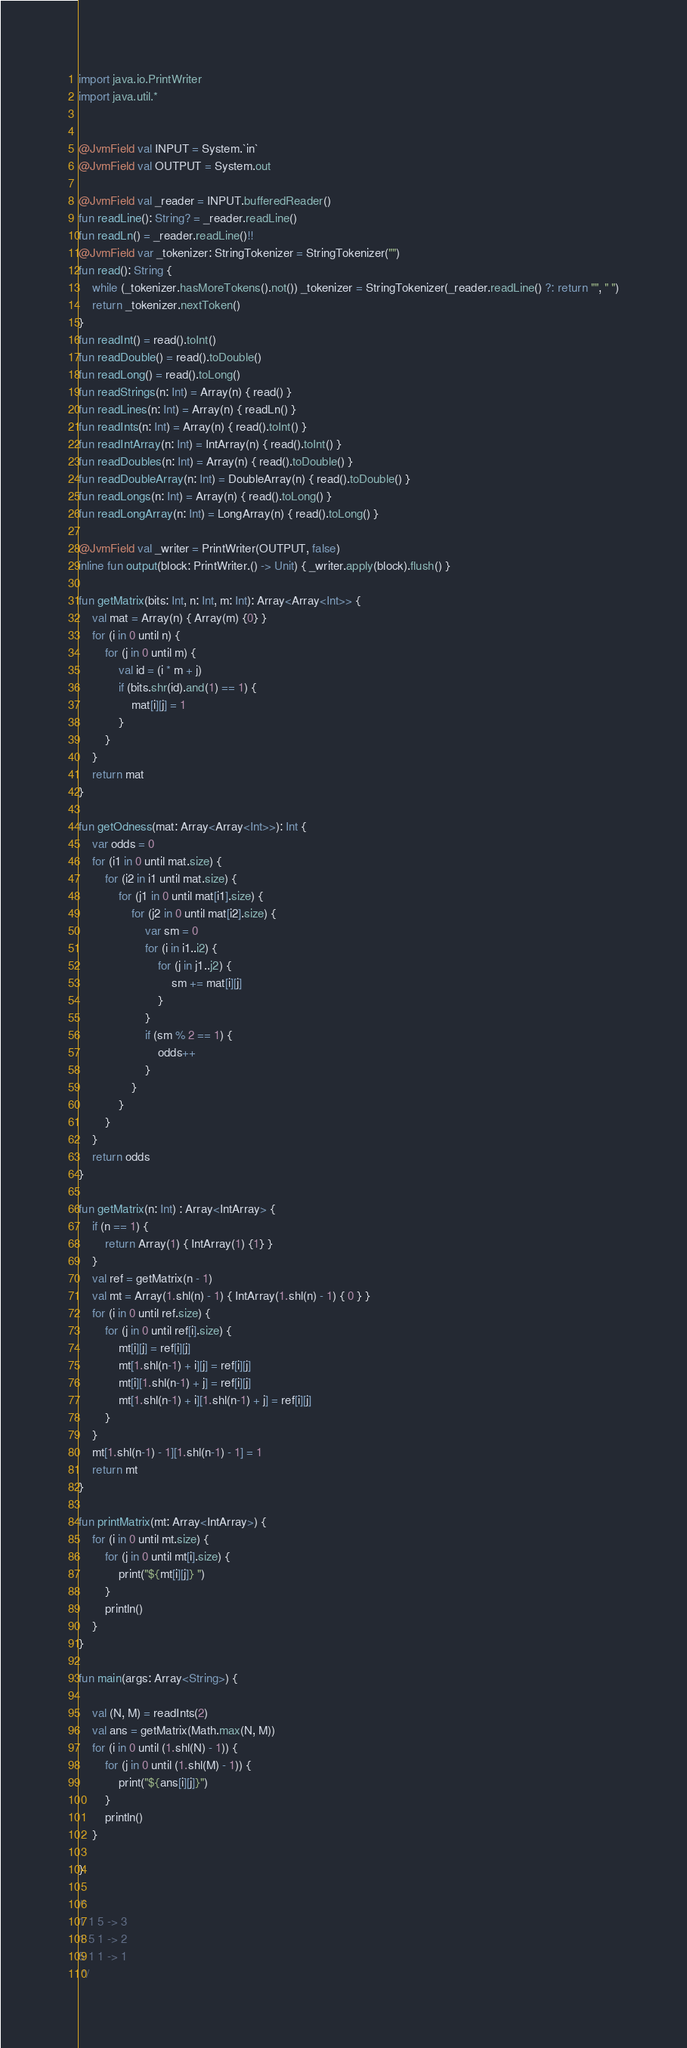<code> <loc_0><loc_0><loc_500><loc_500><_Kotlin_>import java.io.PrintWriter
import java.util.*


@JvmField val INPUT = System.`in`
@JvmField val OUTPUT = System.out

@JvmField val _reader = INPUT.bufferedReader()
fun readLine(): String? = _reader.readLine()
fun readLn() = _reader.readLine()!!
@JvmField var _tokenizer: StringTokenizer = StringTokenizer("")
fun read(): String {
    while (_tokenizer.hasMoreTokens().not()) _tokenizer = StringTokenizer(_reader.readLine() ?: return "", " ")
    return _tokenizer.nextToken()
}
fun readInt() = read().toInt()
fun readDouble() = read().toDouble()
fun readLong() = read().toLong()
fun readStrings(n: Int) = Array(n) { read() }
fun readLines(n: Int) = Array(n) { readLn() }
fun readInts(n: Int) = Array(n) { read().toInt() }
fun readIntArray(n: Int) = IntArray(n) { read().toInt() }
fun readDoubles(n: Int) = Array(n) { read().toDouble() }
fun readDoubleArray(n: Int) = DoubleArray(n) { read().toDouble() }
fun readLongs(n: Int) = Array(n) { read().toLong() }
fun readLongArray(n: Int) = LongArray(n) { read().toLong() }

@JvmField val _writer = PrintWriter(OUTPUT, false)
inline fun output(block: PrintWriter.() -> Unit) { _writer.apply(block).flush() }

fun getMatrix(bits: Int, n: Int, m: Int): Array<Array<Int>> {
    val mat = Array(n) { Array(m) {0} }
    for (i in 0 until n) {
        for (j in 0 until m) {
            val id = (i * m + j)
            if (bits.shr(id).and(1) == 1) {
                mat[i][j] = 1
            }
        }
    }
    return mat
}

fun getOdness(mat: Array<Array<Int>>): Int {
    var odds = 0
    for (i1 in 0 until mat.size) {
        for (i2 in i1 until mat.size) {
            for (j1 in 0 until mat[i1].size) {
                for (j2 in 0 until mat[i2].size) {
                    var sm = 0
                    for (i in i1..i2) {
                        for (j in j1..j2) {
                            sm += mat[i][j]
                        }
                    }
                    if (sm % 2 == 1) {
                        odds++
                    }
                }
            }
        }
    }
    return odds
}

fun getMatrix(n: Int) : Array<IntArray> {
    if (n == 1) {
        return Array(1) { IntArray(1) {1} }
    }
    val ref = getMatrix(n - 1)
    val mt = Array(1.shl(n) - 1) { IntArray(1.shl(n) - 1) { 0 } }
    for (i in 0 until ref.size) {
        for (j in 0 until ref[i].size) {
            mt[i][j] = ref[i][j]
            mt[1.shl(n-1) + i][j] = ref[i][j]
            mt[i][1.shl(n-1) + j] = ref[i][j]
            mt[1.shl(n-1) + i][1.shl(n-1) + j] = ref[i][j]
        }
    }
    mt[1.shl(n-1) - 1][1.shl(n-1) - 1] = 1
    return mt
}

fun printMatrix(mt: Array<IntArray>) {
    for (i in 0 until mt.size) {
        for (j in 0 until mt[i].size) {
            print("${mt[i][j]} ")
        }
        println()
    }
}

fun main(args: Array<String>) {

    val (N, M) = readInts(2)
    val ans = getMatrix(Math.max(N, M))
    for (i in 0 until (1.shl(N) - 1)) {
        for (j in 0 until (1.shl(M) - 1)) {
            print("${ans[i][j]}")
        }
        println()
    }

}

/*
1 1 5 -> 3
1 5 1 -> 2
5 1 1 -> 1
 */
</code> 